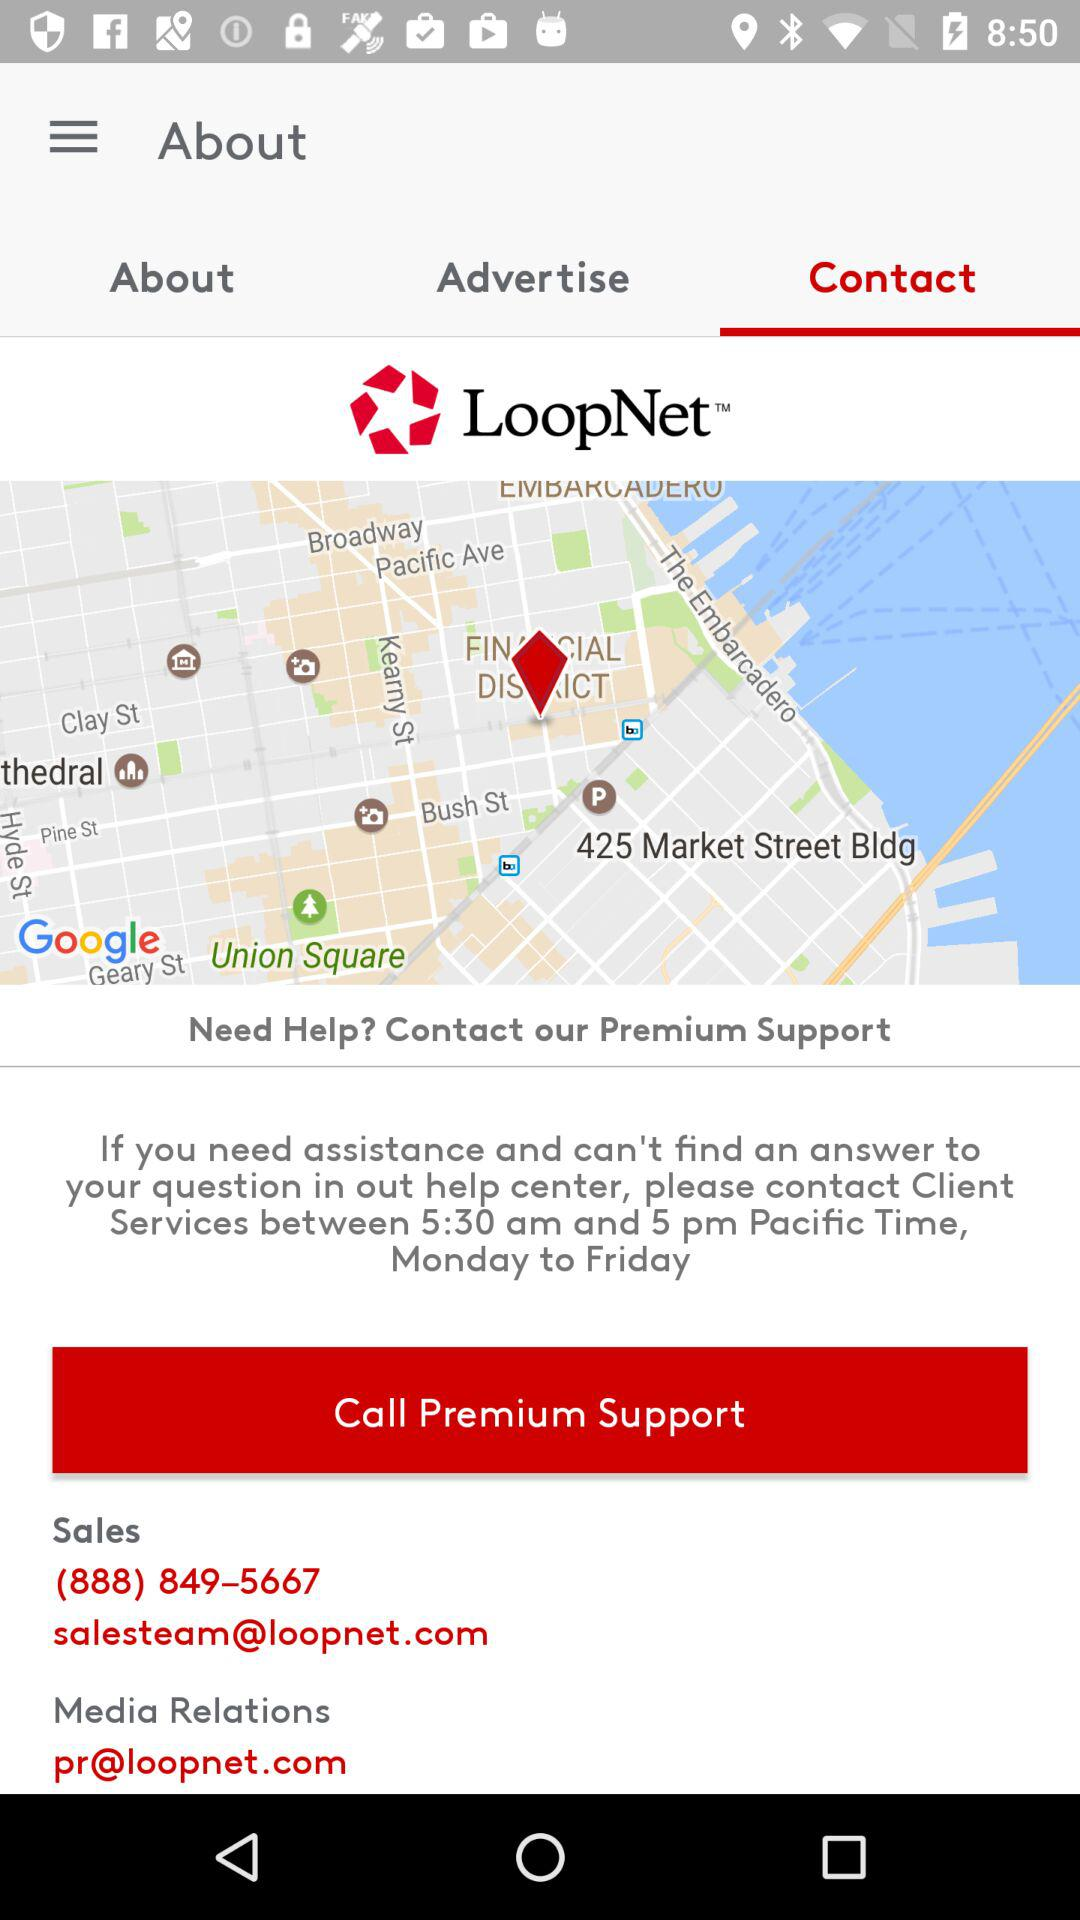Which tab am I on? You are on the "Contact" tab. 